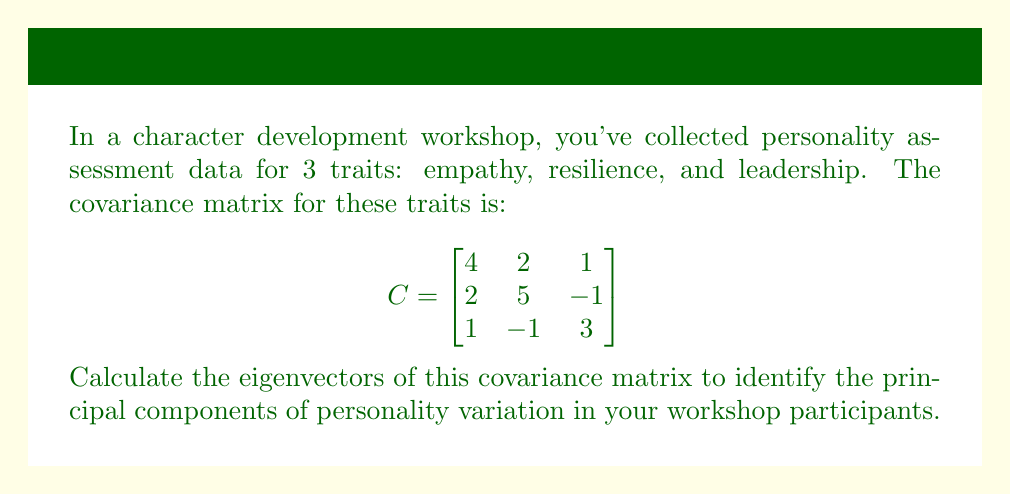Give your solution to this math problem. To find the eigenvectors of the covariance matrix, we follow these steps:

1) First, we need to find the eigenvalues by solving the characteristic equation:
   $\det(C - \lambda I) = 0$

2) Expand the determinant:
   $$\begin{vmatrix}
   4-\lambda & 2 & 1 \\
   2 & 5-\lambda & -1 \\
   1 & -1 & 3-\lambda
   \end{vmatrix} = 0$$

3) This gives us the characteristic polynomial:
   $(4-\lambda)(5-\lambda)(3-\lambda) - 2(3-\lambda) - (5-\lambda) - 4(3-\lambda) + 2 = 0$
   $-\lambda^3 + 12\lambda^2 - 41\lambda + 40 = 0$

4) Solving this equation (using a calculator or computer algebra system), we get:
   $\lambda_1 = 7$, $\lambda_2 = 4$, $\lambda_3 = 1$

5) For each eigenvalue, we solve $(C - \lambda I)v = 0$ to find the corresponding eigenvector:

   For $\lambda_1 = 7$:
   $$\begin{bmatrix}
   -3 & 2 & 1 \\
   2 & -2 & -1 \\
   1 & -1 & -4
   \end{bmatrix}\begin{bmatrix}
   v_1 \\ v_2 \\ v_3
   \end{bmatrix} = \begin{bmatrix}
   0 \\ 0 \\ 0
   \end{bmatrix}$$

   Solving this system, we get $v_1 = (2, 2, 1)^T$

   For $\lambda_2 = 4$:
   $$\begin{bmatrix}
   0 & 2 & 1 \\
   2 & 1 & -1 \\
   1 & -1 & -1
   \end{bmatrix}\begin{bmatrix}
   v_1 \\ v_2 \\ v_3
   \end{bmatrix} = \begin{bmatrix}
   0 \\ 0 \\ 0
   \end{bmatrix}$$

   Solving this system, we get $v_2 = (-1, 0, 2)^T$

   For $\lambda_3 = 1$:
   $$\begin{bmatrix}
   3 & 2 & 1 \\
   2 & 4 & -1 \\
   1 & -1 & 2
   \end{bmatrix}\begin{bmatrix}
   v_1 \\ v_2 \\ v_3
   \end{bmatrix} = \begin{bmatrix}
   0 \\ 0 \\ 0
   \end{bmatrix}$$

   Solving this system, we get $v_3 = (1, -2, 1)^T$

6) Normalize each eigenvector to unit length:
   $v_1 = \frac{1}{\sqrt{9}}(2, 2, 1)^T = \frac{1}{3}(2, 2, 1)^T$
   $v_2 = \frac{1}{\sqrt{5}}(-1, 0, 2)^T$
   $v_3 = \frac{1}{\sqrt{6}}(1, -2, 1)^T$
Answer: $v_1 = \frac{1}{3}(2, 2, 1)^T$, $v_2 = \frac{1}{\sqrt{5}}(-1, 0, 2)^T$, $v_3 = \frac{1}{\sqrt{6}}(1, -2, 1)^T$ 